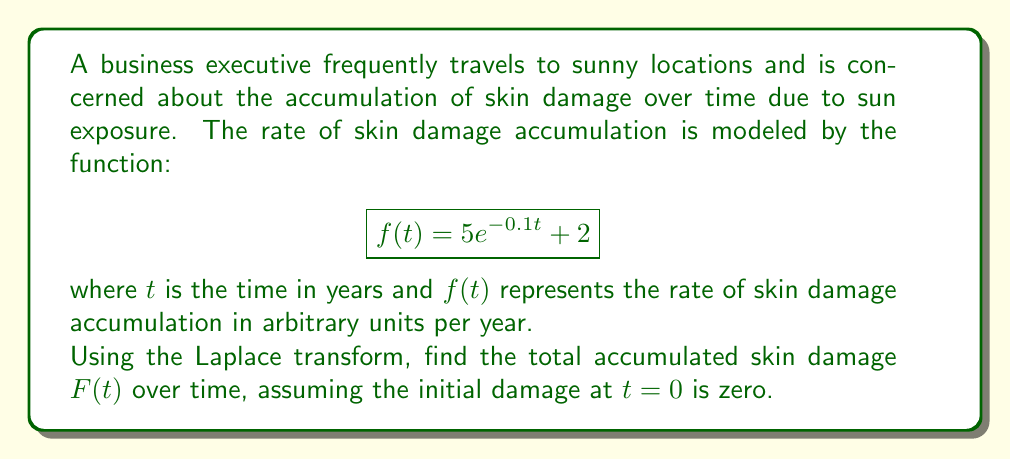What is the answer to this math problem? To solve this problem, we'll use the following steps:

1) The Laplace transform of the accumulation function $F(t)$ is related to the Laplace transform of the rate function $f(t)$ by:

   $$\mathcal{L}\{F(t)\} = \frac{1}{s}\mathcal{L}\{f(t)\}$$

2) Let's find the Laplace transform of $f(t)$:

   $$\mathcal{L}\{f(t)\} = \mathcal{L}\{5e^{-0.1t} + 2\}$$
   $$= 5\mathcal{L}\{e^{-0.1t}\} + 2\mathcal{L}\{1\}$$
   $$= \frac{5}{s+0.1} + \frac{2}{s}$$

3) Now, we can find the Laplace transform of $F(t)$:

   $$\mathcal{L}\{F(t)\} = \frac{1}{s}(\frac{5}{s+0.1} + \frac{2}{s})$$
   $$= \frac{5}{s(s+0.1)} + \frac{2}{s^2}$$

4) To find $F(t)$, we need to take the inverse Laplace transform:

   $$F(t) = \mathcal{L}^{-1}\{\frac{5}{s(s+0.1)} + \frac{2}{s^2}\}$$

5) We can split this into two parts:

   $$F(t) = \mathcal{L}^{-1}\{\frac{5}{s(s+0.1)}\} + \mathcal{L}^{-1}\{\frac{2}{s^2}\}$$

6) For the first part, we can use partial fraction decomposition:

   $$\frac{5}{s(s+0.1)} = \frac{A}{s} + \frac{B}{s+0.1}$$

   Solving for $A$ and $B$, we get $A=50$ and $B=-50$

   So, $$\mathcal{L}^{-1}\{\frac{5}{s(s+0.1)}\} = 50 - 50e^{-0.1t}$$

7) For the second part:

   $$\mathcal{L}^{-1}\{\frac{2}{s^2}\} = 2t$$

8) Combining the results:

   $$F(t) = 50 - 50e^{-0.1t} + 2t$$

This is the total accumulated skin damage over time $t$.
Answer: $F(t) = 50 - 50e^{-0.1t} + 2t$ 